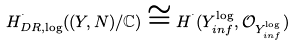<formula> <loc_0><loc_0><loc_500><loc_500>H ^ { ^ { . } } _ { D R , \log } ( ( Y , N ) / \mathbb { C } ) \cong H ^ { ^ { . } } ( Y ^ { \log } _ { i n f } , \mathcal { O } _ { Y ^ { \log } _ { i n f } } )</formula> 